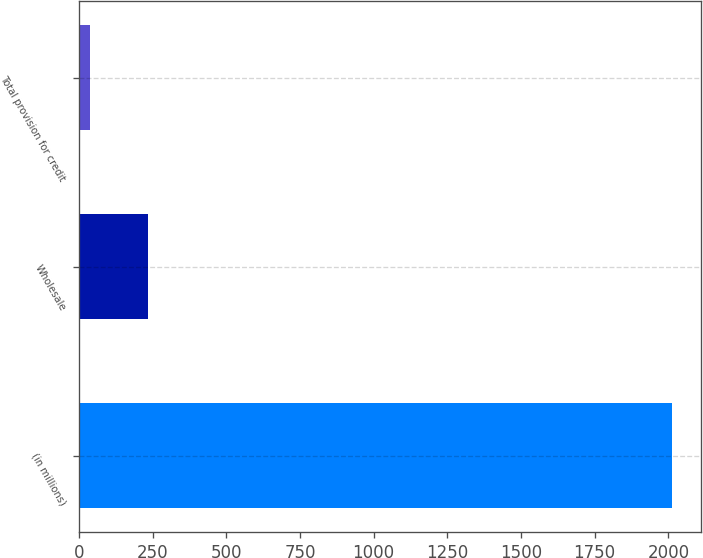Convert chart to OTSL. <chart><loc_0><loc_0><loc_500><loc_500><bar_chart><fcel>(in millions)<fcel>Wholesale<fcel>Total provision for credit<nl><fcel>2011<fcel>235.3<fcel>38<nl></chart> 